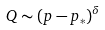Convert formula to latex. <formula><loc_0><loc_0><loc_500><loc_500>Q \sim ( p - p _ { * } ) ^ { \delta }</formula> 